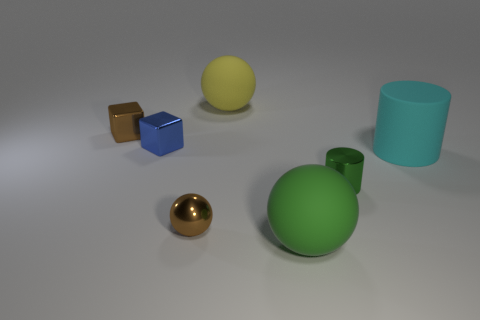Subtract all brown shiny spheres. How many spheres are left? 2 Add 3 small blue cubes. How many objects exist? 10 Subtract all spheres. How many objects are left? 4 Subtract 0 brown cylinders. How many objects are left? 7 Subtract all brown metal spheres. Subtract all large yellow metallic blocks. How many objects are left? 6 Add 3 tiny shiny balls. How many tiny shiny balls are left? 4 Add 6 small red rubber cubes. How many small red rubber cubes exist? 6 